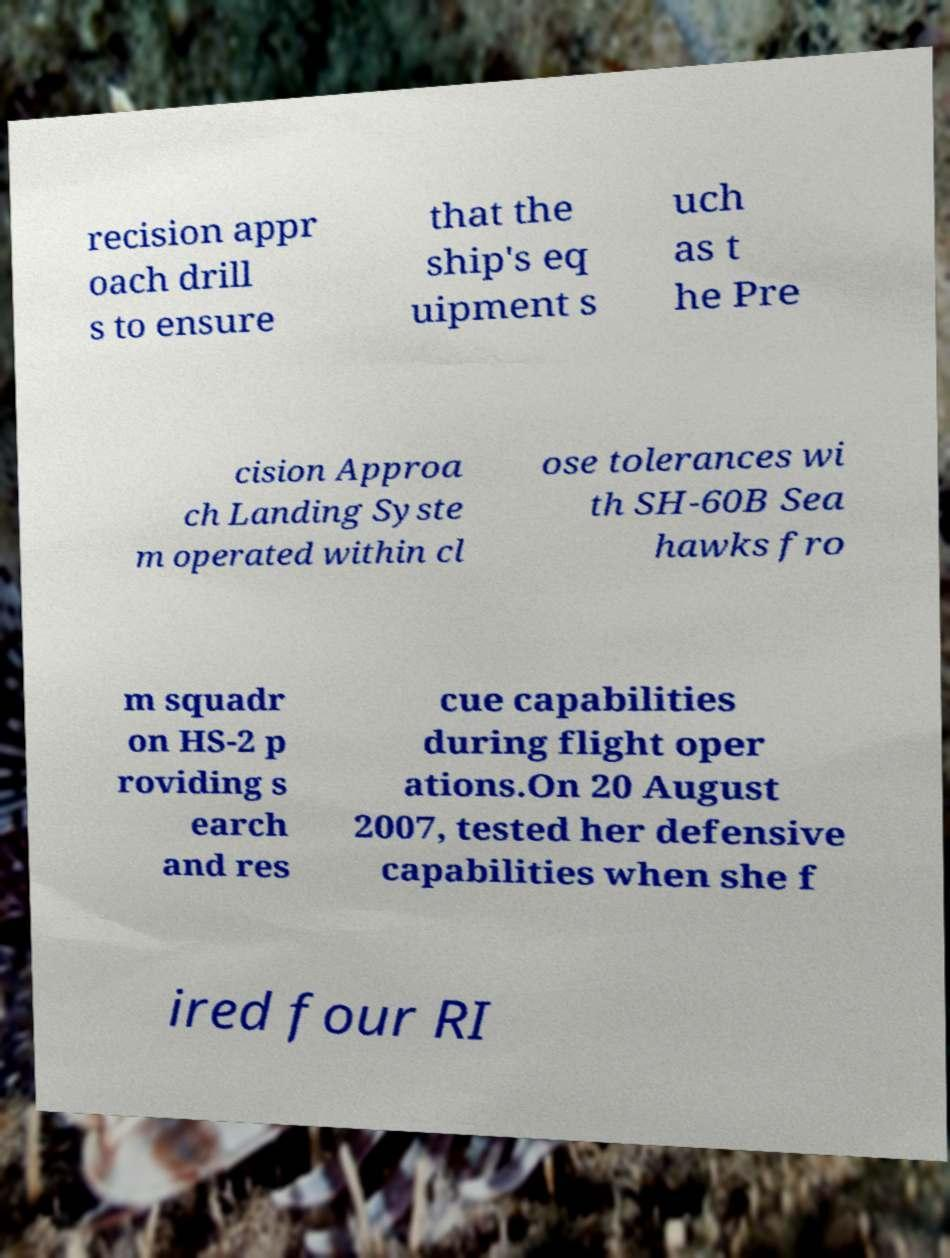Can you read and provide the text displayed in the image?This photo seems to have some interesting text. Can you extract and type it out for me? recision appr oach drill s to ensure that the ship's eq uipment s uch as t he Pre cision Approa ch Landing Syste m operated within cl ose tolerances wi th SH-60B Sea hawks fro m squadr on HS-2 p roviding s earch and res cue capabilities during flight oper ations.On 20 August 2007, tested her defensive capabilities when she f ired four RI 